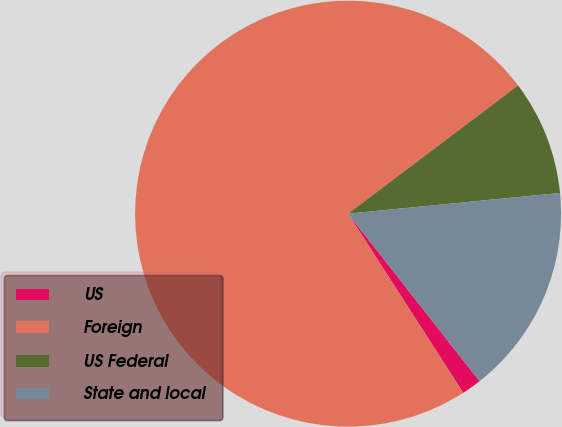Convert chart to OTSL. <chart><loc_0><loc_0><loc_500><loc_500><pie_chart><fcel>US<fcel>Foreign<fcel>US Federal<fcel>State and local<nl><fcel>1.5%<fcel>73.81%<fcel>8.73%<fcel>15.96%<nl></chart> 